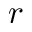<formula> <loc_0><loc_0><loc_500><loc_500>r</formula> 